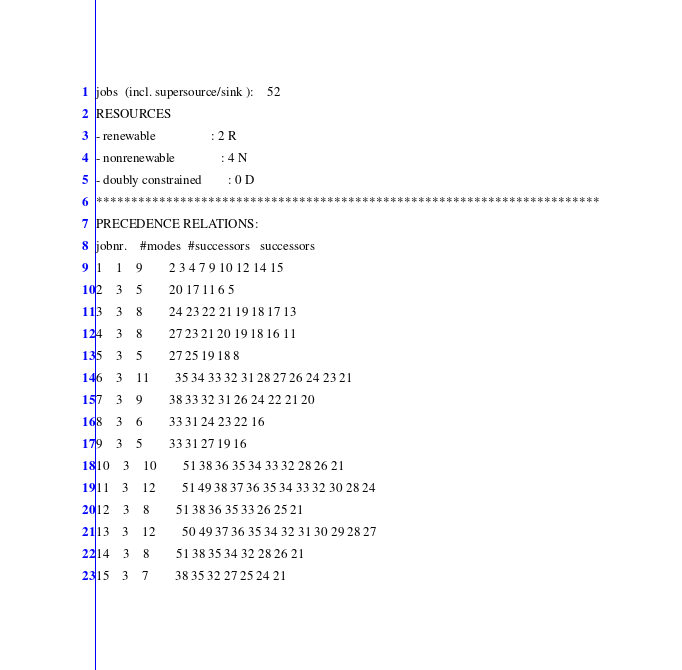<code> <loc_0><loc_0><loc_500><loc_500><_ObjectiveC_>jobs  (incl. supersource/sink ):	52
RESOURCES
- renewable                 : 2 R
- nonrenewable              : 4 N
- doubly constrained        : 0 D
************************************************************************
PRECEDENCE RELATIONS:
jobnr.    #modes  #successors   successors
1	1	9		2 3 4 7 9 10 12 14 15 
2	3	5		20 17 11 6 5 
3	3	8		24 23 22 21 19 18 17 13 
4	3	8		27 23 21 20 19 18 16 11 
5	3	5		27 25 19 18 8 
6	3	11		35 34 33 32 31 28 27 26 24 23 21 
7	3	9		38 33 32 31 26 24 22 21 20 
8	3	6		33 31 24 23 22 16 
9	3	5		33 31 27 19 16 
10	3	10		51 38 36 35 34 33 32 28 26 21 
11	3	12		51 49 38 37 36 35 34 33 32 30 28 24 
12	3	8		51 38 36 35 33 26 25 21 
13	3	12		50 49 37 36 35 34 32 31 30 29 28 27 
14	3	8		51 38 35 34 32 28 26 21 
15	3	7		38 35 32 27 25 24 21 </code> 